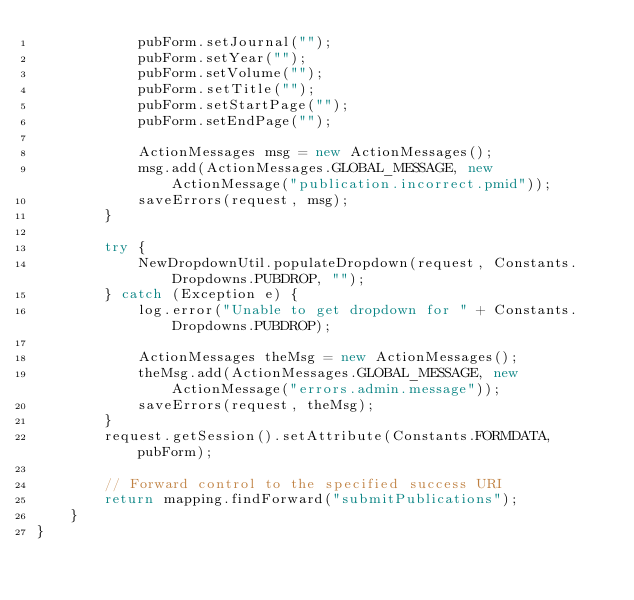Convert code to text. <code><loc_0><loc_0><loc_500><loc_500><_Java_>            pubForm.setJournal("");
            pubForm.setYear("");
            pubForm.setVolume("");
            pubForm.setTitle("");
            pubForm.setStartPage("");
            pubForm.setEndPage("");

            ActionMessages msg = new ActionMessages();
            msg.add(ActionMessages.GLOBAL_MESSAGE, new ActionMessage("publication.incorrect.pmid"));
            saveErrors(request, msg);
        }

        try {
            NewDropdownUtil.populateDropdown(request, Constants.Dropdowns.PUBDROP, "");
        } catch (Exception e) {
            log.error("Unable to get dropdown for " + Constants.Dropdowns.PUBDROP);

            ActionMessages theMsg = new ActionMessages();
            theMsg.add(ActionMessages.GLOBAL_MESSAGE, new ActionMessage("errors.admin.message"));
            saveErrors(request, theMsg);
        }
        request.getSession().setAttribute(Constants.FORMDATA, pubForm);

        // Forward control to the specified success URI
        return mapping.findForward("submitPublications");
    }
}
</code> 